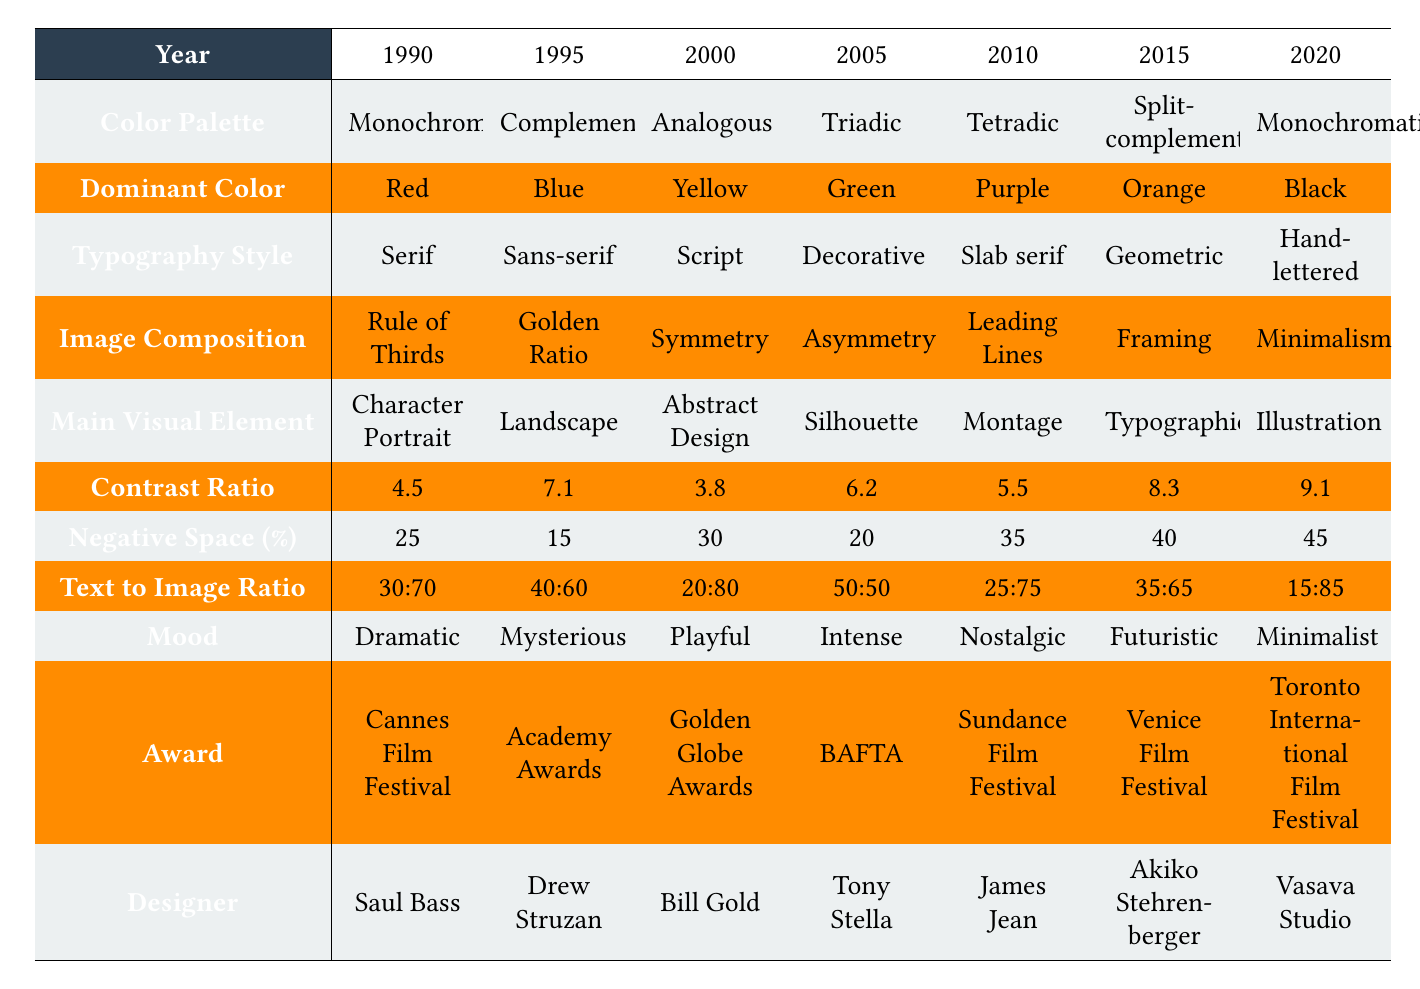What was the dominant color in 2005? According to the table, the dominant color listed for the year 2005 is Green.
Answer: Green Which year had the highest contrast ratio? By examining the contrast ratios provided, the highest value is 9.1, which corresponds to the year 2020.
Answer: 2020 What is the color palette used in 2010? The table shows that the color palette for the year 2010 is Tetradic.
Answer: Tetradic Did any year utilize a decorative typography style? The table shows that the typography style used in 2005 was Decorative, which confirms that yes, it did.
Answer: Yes What is the average negative space percentage across the years? The percentages are 25, 15, 30, 20, 35, 40, and 45. Summing these gives 210, and dividing by 7 (the number of years) results in an average of 30.
Answer: 30 Which mood corresponds to the award-winning poster from 2015? The mood listed for the year 2015 is Futuristic.
Answer: Futuristic How many years featured a monochromatic color palette? The data indicates that 1990 and 2020 both used a monochromatic color palette, amounting to 2 years total.
Answer: 2 Which year showed the lowest percentage of negative space? The year 1995 shows the lowest percentage of negative space, at 15%.
Answer: 1995 Is the text to image ratio mostly higher for earlier years compared to later years? By comparing the text to image ratios, it appears that earlier years (1990 and 1995) have ratios ranging closer to 30:70 and 40:60, which are higher in text content than the later years like 2020 (15:85). Therefore, this statement is true.
Answer: Yes Which designer created the poster for the movie associated with the 2000 awards? The table names Bill Gold as the designer linked with the year 2000.
Answer: Bill Gold What trend can be observed in contrast ratios from 1990 to 2020? By analyzing the contrast ratios over the years, it's observed that the values generally increase, starting at 4.5 in 1990 and reaching 9.1 in 2020.
Answer: Increasing trend 